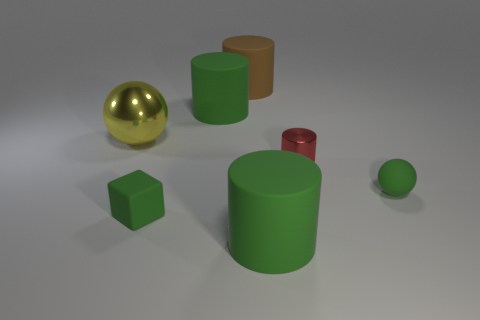There is a cube that is made of the same material as the large brown object; what is its size?
Your answer should be compact. Small. What color is the tiny object that is to the left of the tiny green ball and in front of the tiny cylinder?
Your answer should be very brief. Green. What number of green cubes are the same size as the yellow ball?
Your answer should be compact. 0. There is a matte thing that is behind the green matte block and to the right of the big brown matte object; what size is it?
Make the answer very short. Small. There is a small green object that is right of the green object in front of the tiny matte cube; how many matte things are in front of it?
Keep it short and to the point. 2. Is there a large matte thing of the same color as the tiny matte sphere?
Give a very brief answer. Yes. What is the color of the rubber object that is the same size as the green matte ball?
Ensure brevity in your answer.  Green. There is a small green matte thing that is on the right side of the green rubber cylinder that is right of the big green thing that is behind the green matte block; what is its shape?
Provide a succinct answer. Sphere. There is a big cylinder in front of the big sphere; how many large cylinders are to the left of it?
Your response must be concise. 2. There is a metal thing that is in front of the big sphere; is its shape the same as the big green thing that is in front of the tiny metallic object?
Provide a succinct answer. Yes. 